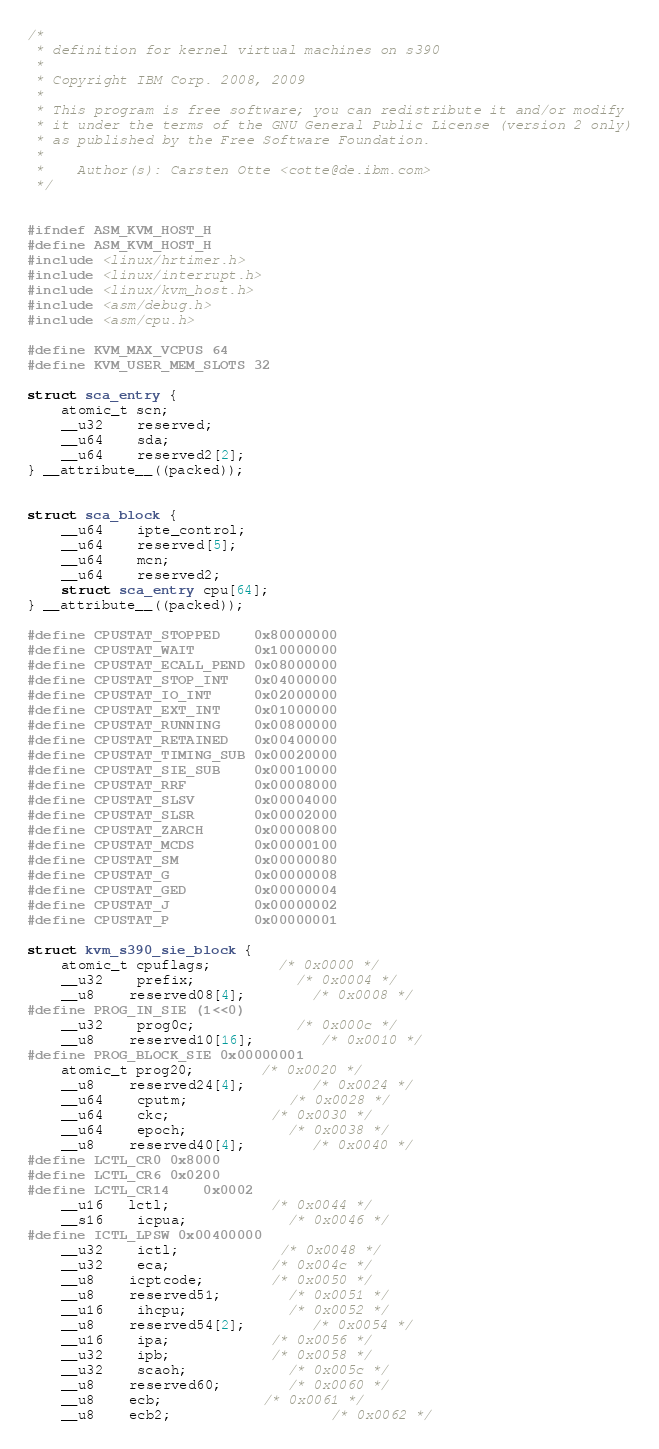<code> <loc_0><loc_0><loc_500><loc_500><_C_>/*
 * definition for kernel virtual machines on s390
 *
 * Copyright IBM Corp. 2008, 2009
 *
 * This program is free software; you can redistribute it and/or modify
 * it under the terms of the GNU General Public License (version 2 only)
 * as published by the Free Software Foundation.
 *
 *    Author(s): Carsten Otte <cotte@de.ibm.com>
 */


#ifndef ASM_KVM_HOST_H
#define ASM_KVM_HOST_H
#include <linux/hrtimer.h>
#include <linux/interrupt.h>
#include <linux/kvm_host.h>
#include <asm/debug.h>
#include <asm/cpu.h>

#define KVM_MAX_VCPUS 64
#define KVM_USER_MEM_SLOTS 32

struct sca_entry {
	atomic_t scn;
	__u32	reserved;
	__u64	sda;
	__u64	reserved2[2];
} __attribute__((packed));


struct sca_block {
	__u64	ipte_control;
	__u64	reserved[5];
	__u64	mcn;
	__u64	reserved2;
	struct sca_entry cpu[64];
} __attribute__((packed));

#define CPUSTAT_STOPPED    0x80000000
#define CPUSTAT_WAIT       0x10000000
#define CPUSTAT_ECALL_PEND 0x08000000
#define CPUSTAT_STOP_INT   0x04000000
#define CPUSTAT_IO_INT     0x02000000
#define CPUSTAT_EXT_INT    0x01000000
#define CPUSTAT_RUNNING    0x00800000
#define CPUSTAT_RETAINED   0x00400000
#define CPUSTAT_TIMING_SUB 0x00020000
#define CPUSTAT_SIE_SUB    0x00010000
#define CPUSTAT_RRF        0x00008000
#define CPUSTAT_SLSV       0x00004000
#define CPUSTAT_SLSR       0x00002000
#define CPUSTAT_ZARCH      0x00000800
#define CPUSTAT_MCDS       0x00000100
#define CPUSTAT_SM         0x00000080
#define CPUSTAT_G          0x00000008
#define CPUSTAT_GED        0x00000004
#define CPUSTAT_J          0x00000002
#define CPUSTAT_P          0x00000001

struct kvm_s390_sie_block {
	atomic_t cpuflags;		/* 0x0000 */
	__u32	prefix;			/* 0x0004 */
	__u8	reserved08[4];		/* 0x0008 */
#define PROG_IN_SIE (1<<0)
	__u32	prog0c;			/* 0x000c */
	__u8	reserved10[16];		/* 0x0010 */
#define PROG_BLOCK_SIE 0x00000001
	atomic_t prog20;		/* 0x0020 */
	__u8	reserved24[4];		/* 0x0024 */
	__u64	cputm;			/* 0x0028 */
	__u64	ckc;			/* 0x0030 */
	__u64	epoch;			/* 0x0038 */
	__u8	reserved40[4];		/* 0x0040 */
#define LCTL_CR0	0x8000
#define LCTL_CR6	0x0200
#define LCTL_CR14	0x0002
	__u16   lctl;			/* 0x0044 */
	__s16	icpua;			/* 0x0046 */
#define ICTL_LPSW 0x00400000
	__u32	ictl;			/* 0x0048 */
	__u32	eca;			/* 0x004c */
	__u8	icptcode;		/* 0x0050 */
	__u8	reserved51;		/* 0x0051 */
	__u16	ihcpu;			/* 0x0052 */
	__u8	reserved54[2];		/* 0x0054 */
	__u16	ipa;			/* 0x0056 */
	__u32	ipb;			/* 0x0058 */
	__u32	scaoh;			/* 0x005c */
	__u8	reserved60;		/* 0x0060 */
	__u8	ecb;			/* 0x0061 */
	__u8    ecb2;                   /* 0x0062 */</code> 